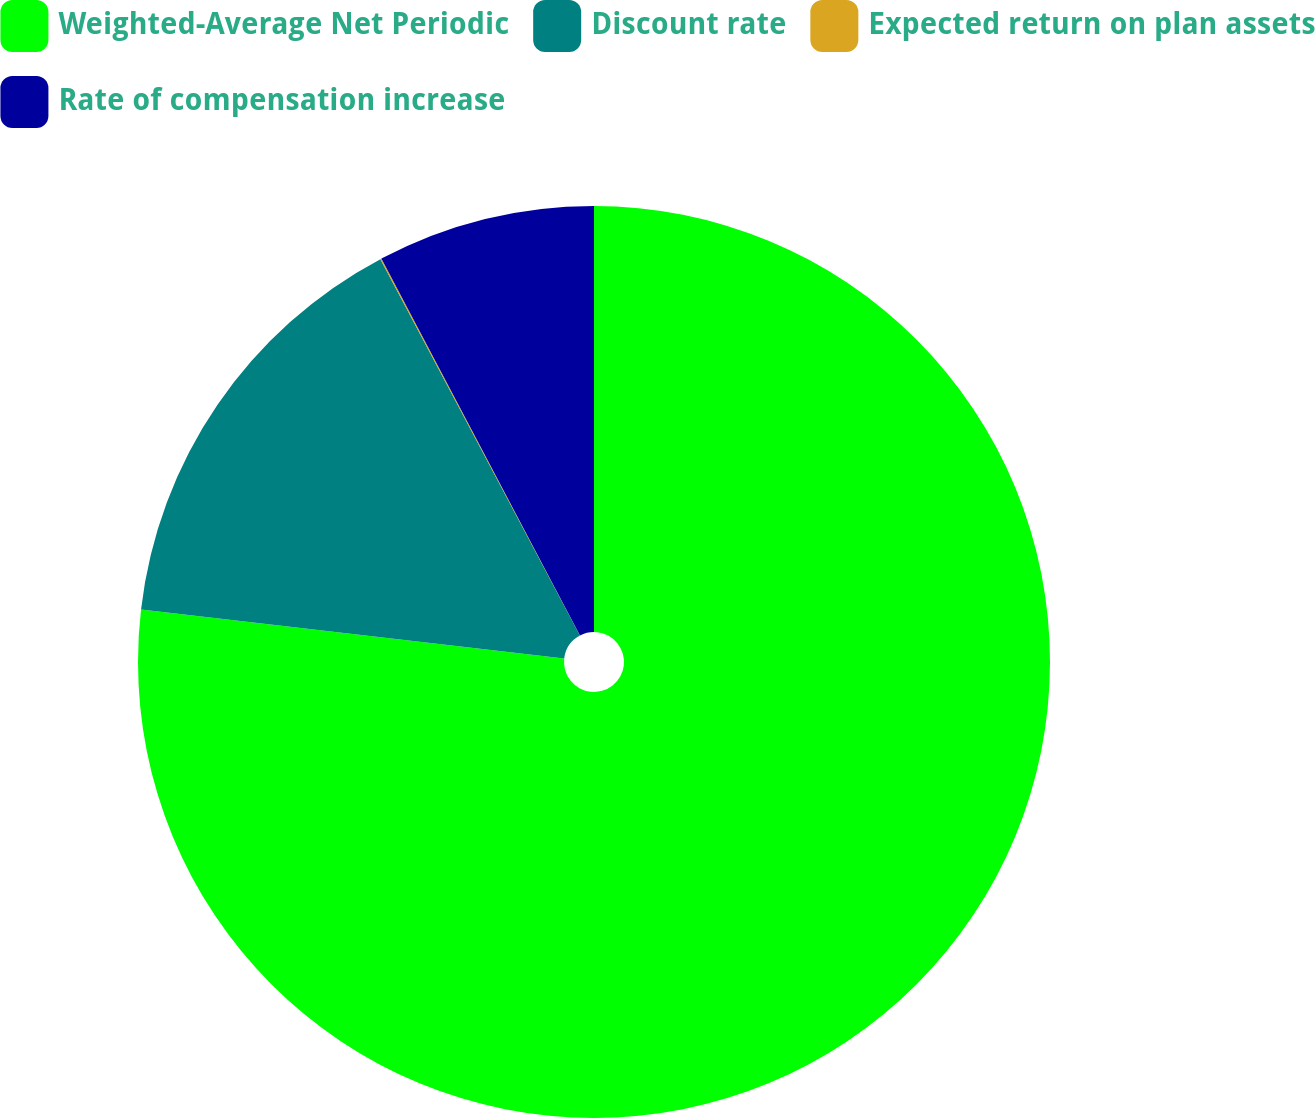Convert chart. <chart><loc_0><loc_0><loc_500><loc_500><pie_chart><fcel>Weighted-Average Net Periodic<fcel>Discount rate<fcel>Expected return on plan assets<fcel>Rate of compensation increase<nl><fcel>76.84%<fcel>15.4%<fcel>0.04%<fcel>7.72%<nl></chart> 